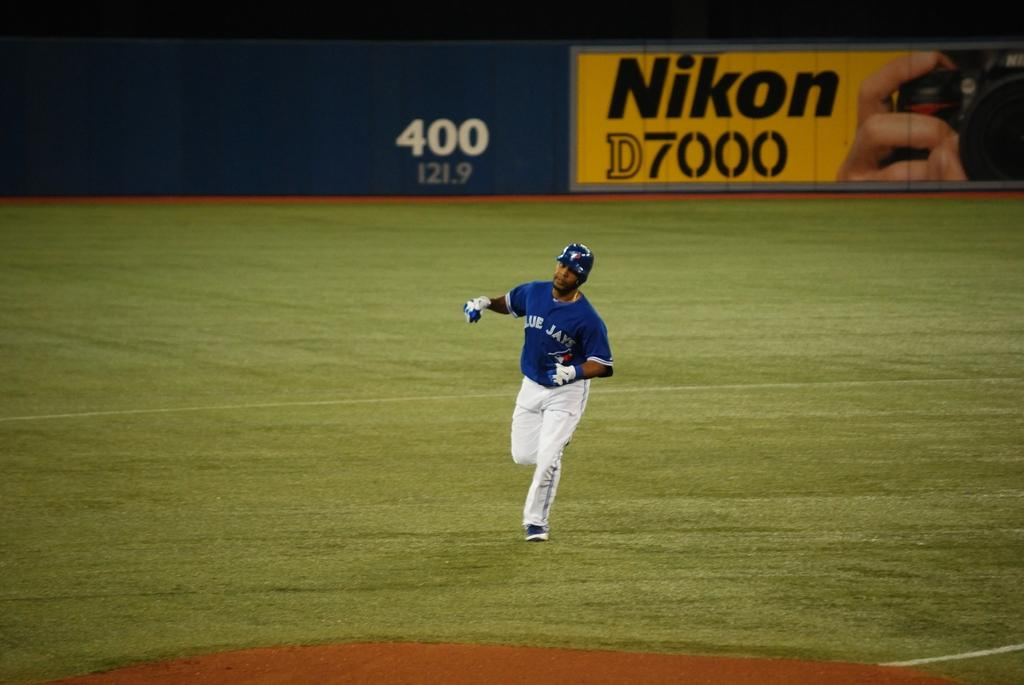<image>
Offer a succinct explanation of the picture presented. A Blue Jays baseball player runs across the field in front of a Nikon D7000 sign. 